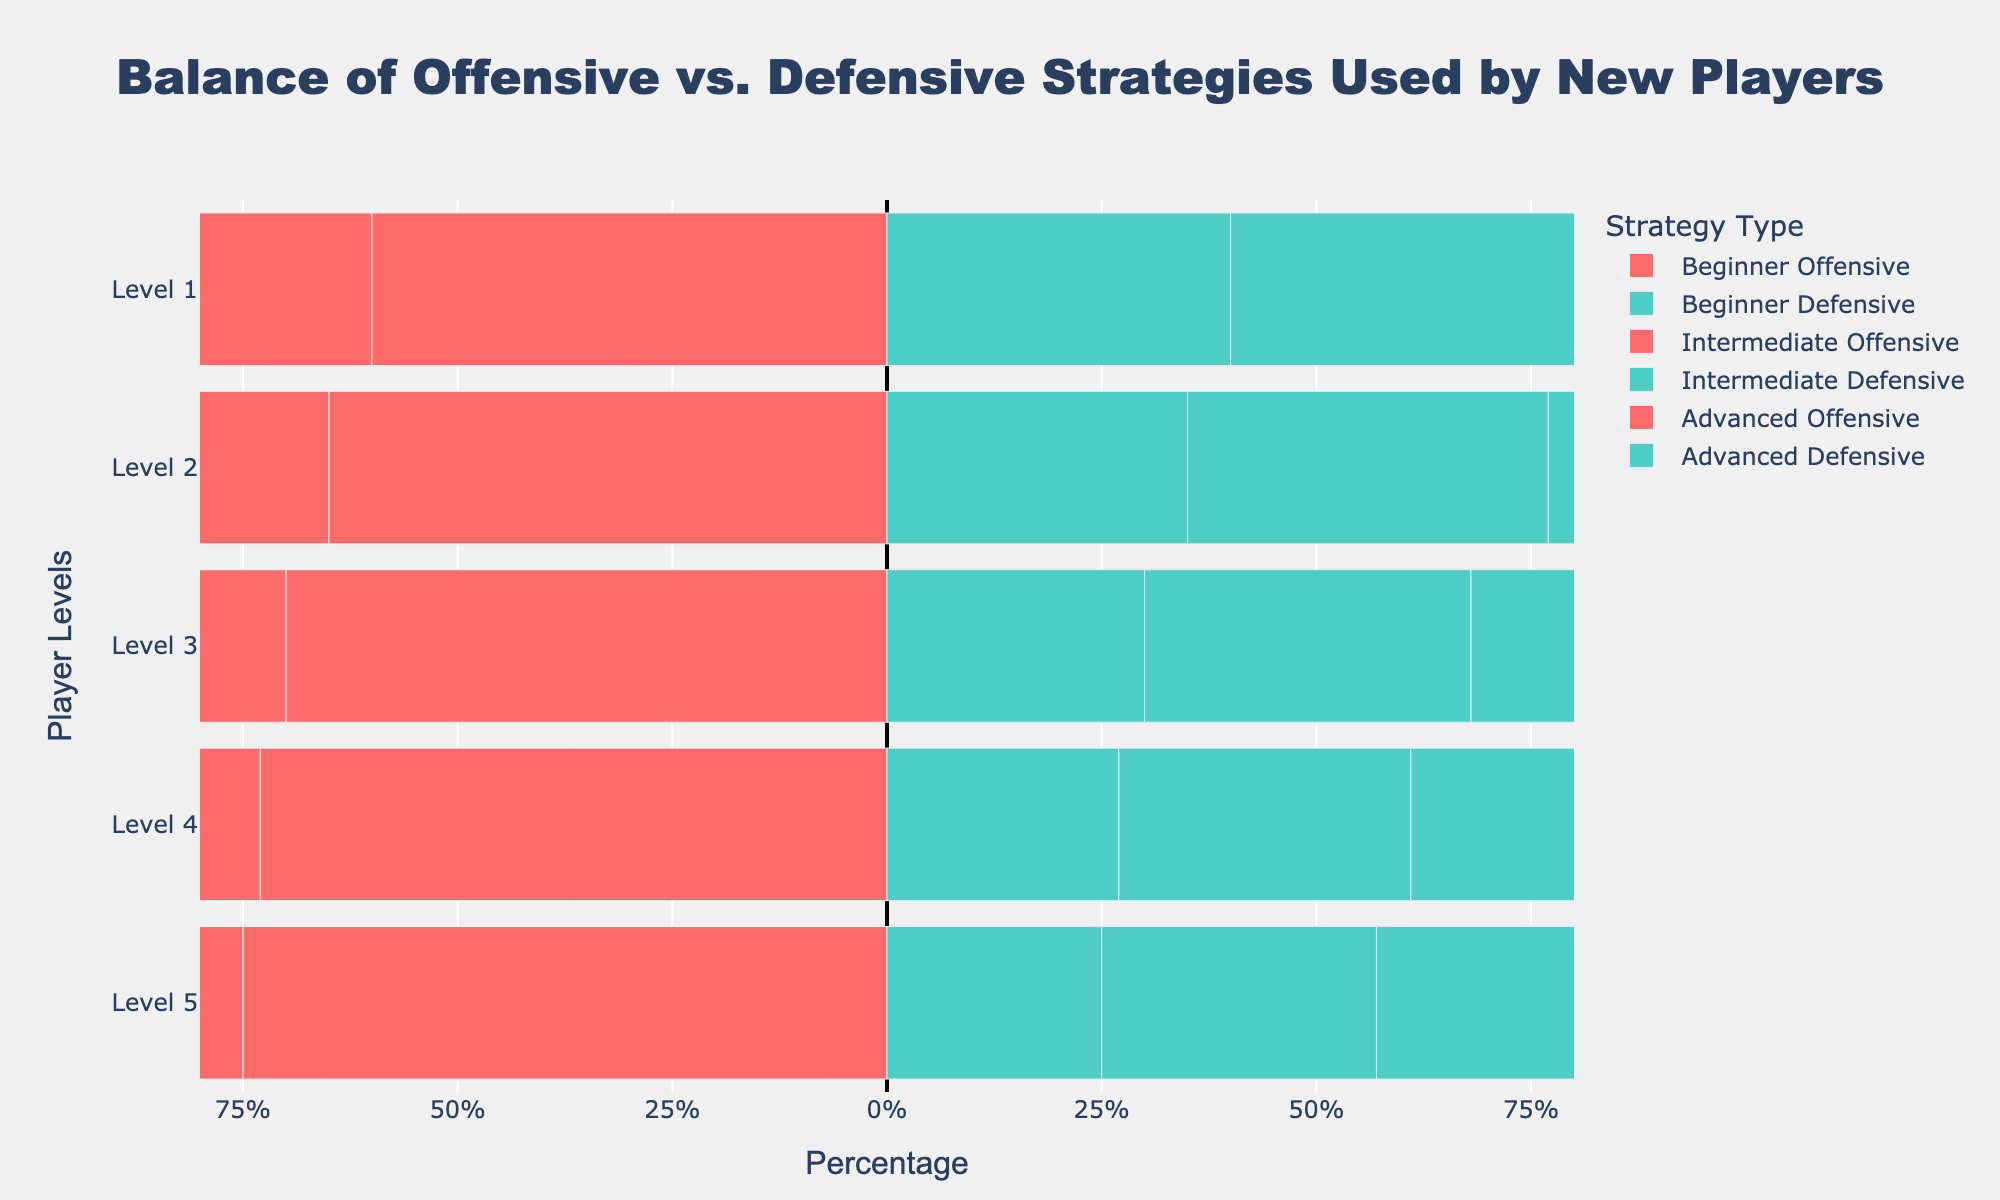What is the percentage of offensive strategies used by Beginner level players at Level 3? Find the bar representing Beginner level players at Level 3 and refer to the percentage marked on the offensive side (red bar). The value reads 70%.
Answer: 70% How do the percentages of offensive strategies change from Intermediate to Advanced level at Level 5? Locate the red bars for Intermediate and Advanced levels at Level 5, then compare their lengths. The Intermediate level shows 68% offensive, while the Advanced level shows 57% offensive.
Answer: It decreases by 11% What is the overall trend in the use of offensive strategies among Beginner players from Level 1 to Level 5? Observe the red bars representing Beginner players across Levels 1 to 5 and note the increasing pattern. The percentages are 60%, 65%, 70%, 73%, and 75%.
Answer: Increasing trend Between which two player levels is the difference in defensive strategies the greatest for Advanced players? Compare the green bars representing different player levels for Advanced players and calculate the differences. Defensive percentages are 50%, 48%, 46%, 45%, and 43%. The largest change is between Level 1 (50%) and Level 5 (43%).
Answer: Level 1 and Level 5 What is the average percentage of offensive strategies used by Intermediate players across all levels? Sum the percentages of offensive strategies used by Intermediate players at each level and divide by the number of levels (5). The percentages are 55%, 58%, 62%, 66%, and 68%. (55 + 58 + 62 + 66 + 68) / 5 = 309 / 5 = 61.8%
Answer: 61.8% Does any level of Advanced players have equal use of offensive and defensive strategies? Check each level for Advanced players to see if the red and green bars are equal in length. At Level 1, both offensive and defensive strategies are used 50%.
Answer: Yes, at Level 1 Which player level has the highest percentage of defensive strategies for Intermediate players? Identify the longest green bar among Intermediate players across all levels. The maximum percentage of defensive strategies for Intermediate players is 45% at Level 1.
Answer: Level 1 By how much does the percentage of defensive strategies decrease from Beginner to Intermediate players at Level 3? Compare the green bars for Beginner (30%) and Intermediate (38%) players at Level 3 and calculate the difference: 38% - 30% = 8%.
Answer: 8% 